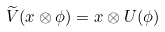<formula> <loc_0><loc_0><loc_500><loc_500>\widetilde { V } ( x \otimes \phi ) = x \otimes U ( \phi )</formula> 